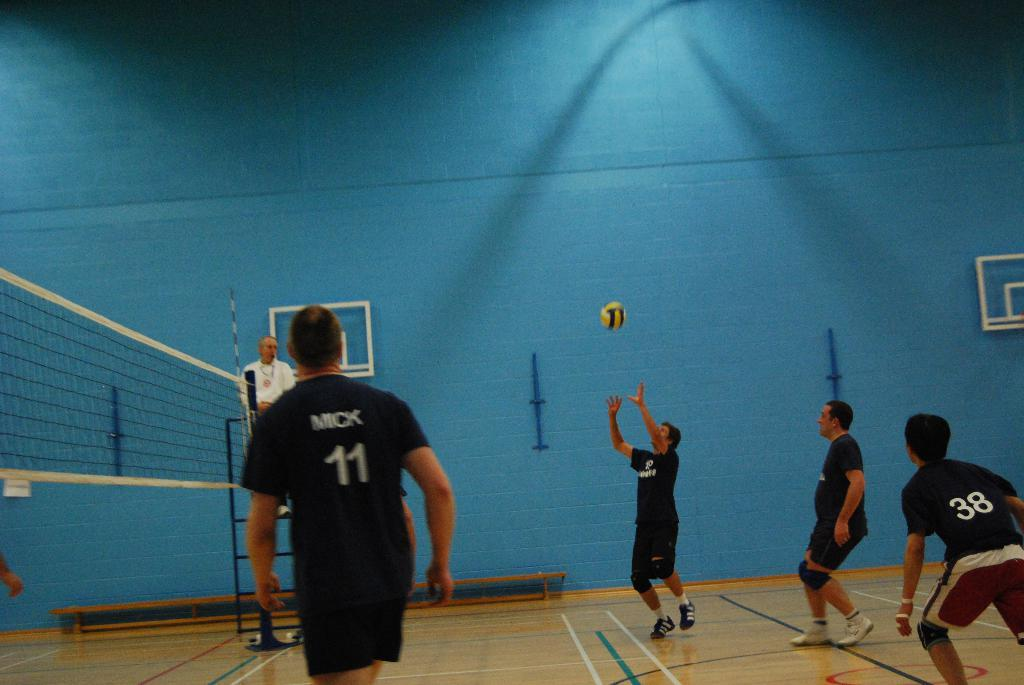<image>
Create a compact narrative representing the image presented. Player number 11 on the mens volleyball team is named Mick. 